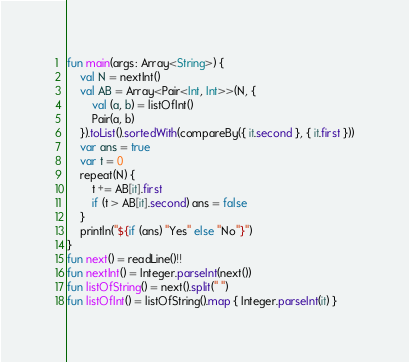Convert code to text. <code><loc_0><loc_0><loc_500><loc_500><_Kotlin_>fun main(args: Array<String>) {
    val N = nextInt()
    val AB = Array<Pair<Int, Int>>(N, {
        val (a, b) = listOfInt()
        Pair(a, b)
    }).toList().sortedWith(compareBy({ it.second }, { it.first }))
    var ans = true
    var t = 0
    repeat(N) {
        t += AB[it].first
        if (t > AB[it].second) ans = false
    }
    println("${if (ans) "Yes" else "No"}")
}
fun next() = readLine()!!
fun nextInt() = Integer.parseInt(next())
fun listOfString() = next().split(" ")
fun listOfInt() = listOfString().map { Integer.parseInt(it) }
</code> 